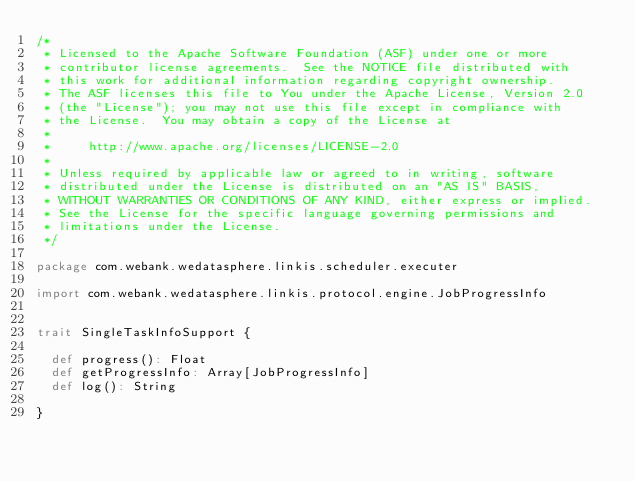Convert code to text. <code><loc_0><loc_0><loc_500><loc_500><_Scala_>/*
 * Licensed to the Apache Software Foundation (ASF) under one or more
 * contributor license agreements.  See the NOTICE file distributed with
 * this work for additional information regarding copyright ownership.
 * The ASF licenses this file to You under the Apache License, Version 2.0
 * (the "License"); you may not use this file except in compliance with
 * the License.  You may obtain a copy of the License at
 *
 *     http://www.apache.org/licenses/LICENSE-2.0
 *
 * Unless required by applicable law or agreed to in writing, software
 * distributed under the License is distributed on an "AS IS" BASIS,
 * WITHOUT WARRANTIES OR CONDITIONS OF ANY KIND, either express or implied.
 * See the License for the specific language governing permissions and
 * limitations under the License.
 */

package com.webank.wedatasphere.linkis.scheduler.executer

import com.webank.wedatasphere.linkis.protocol.engine.JobProgressInfo


trait SingleTaskInfoSupport {

  def progress(): Float
  def getProgressInfo: Array[JobProgressInfo]
  def log(): String

}</code> 